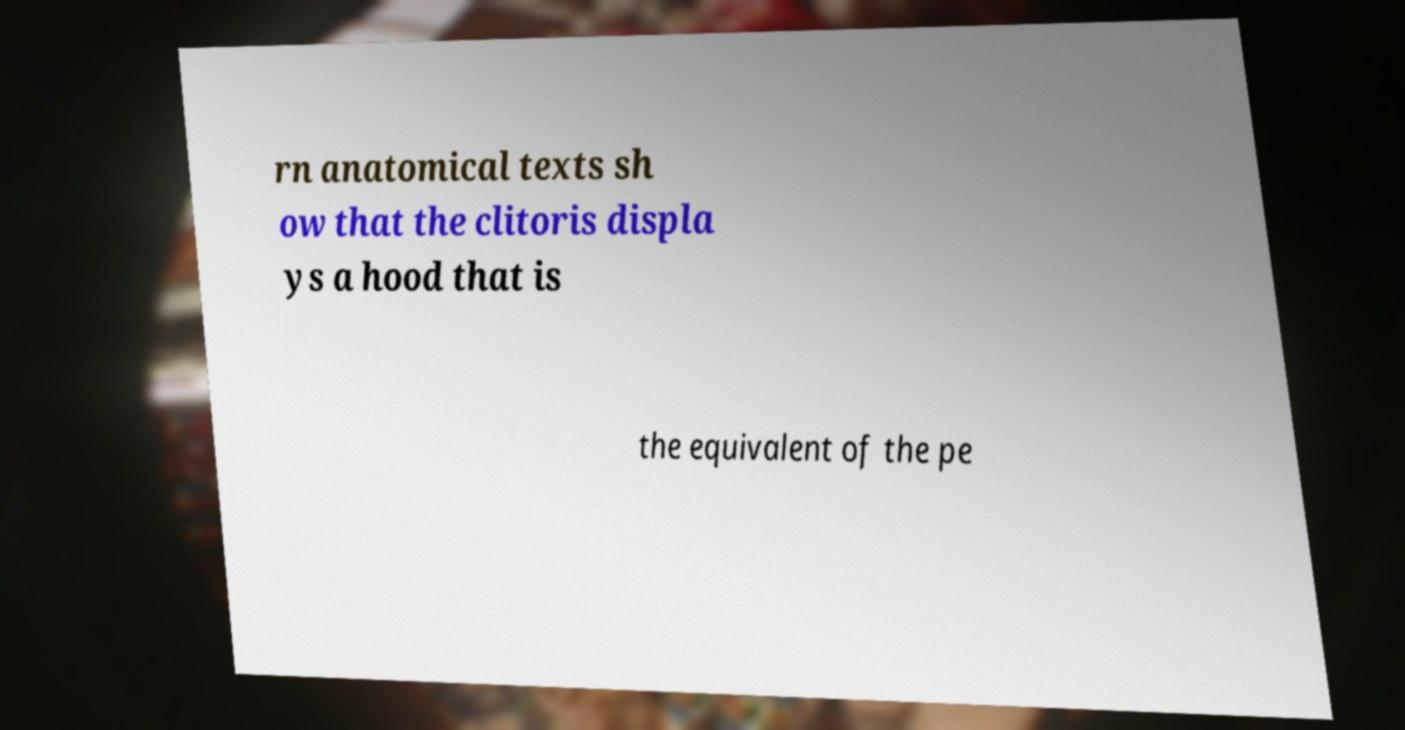There's text embedded in this image that I need extracted. Can you transcribe it verbatim? rn anatomical texts sh ow that the clitoris displa ys a hood that is the equivalent of the pe 